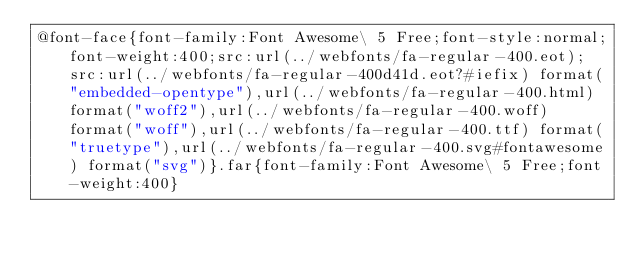<code> <loc_0><loc_0><loc_500><loc_500><_CSS_>@font-face{font-family:Font Awesome\ 5 Free;font-style:normal;font-weight:400;src:url(../webfonts/fa-regular-400.eot);src:url(../webfonts/fa-regular-400d41d.eot?#iefix) format("embedded-opentype"),url(../webfonts/fa-regular-400.html) format("woff2"),url(../webfonts/fa-regular-400.woff) format("woff"),url(../webfonts/fa-regular-400.ttf) format("truetype"),url(../webfonts/fa-regular-400.svg#fontawesome) format("svg")}.far{font-family:Font Awesome\ 5 Free;font-weight:400}</code> 